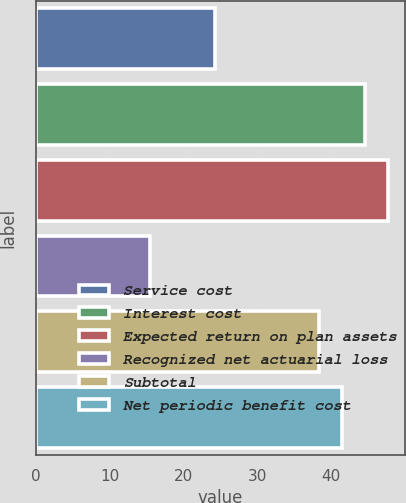Convert chart. <chart><loc_0><loc_0><loc_500><loc_500><bar_chart><fcel>Service cost<fcel>Interest cost<fcel>Expected return on plan assets<fcel>Recognized net actuarial loss<fcel>Subtotal<fcel>Net periodic benefit cost<nl><fcel>24.2<fcel>44.54<fcel>47.61<fcel>15.5<fcel>38.4<fcel>41.47<nl></chart> 